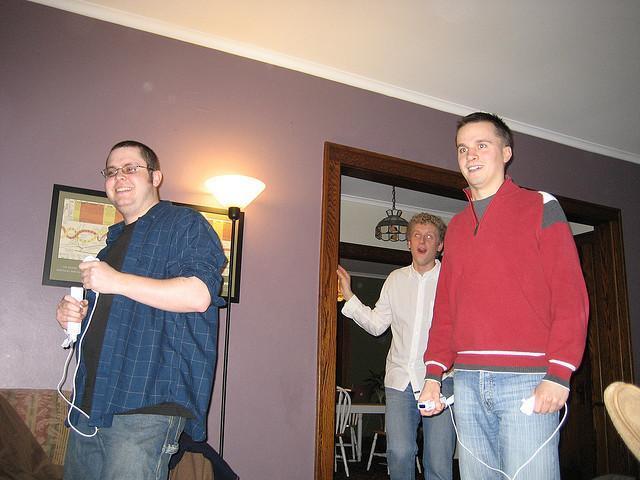How many men are standing in this room?
Give a very brief answer. 3. How many people are there?
Give a very brief answer. 3. 